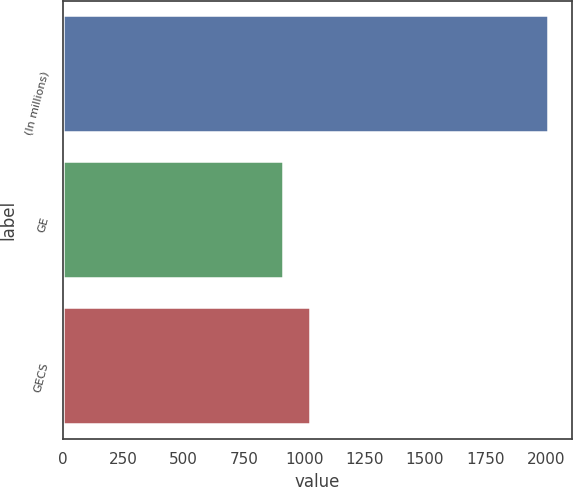Convert chart. <chart><loc_0><loc_0><loc_500><loc_500><bar_chart><fcel>(In millions)<fcel>GE<fcel>GECS<nl><fcel>2008<fcel>912<fcel>1021.6<nl></chart> 